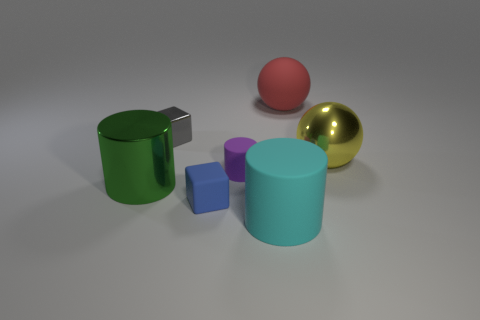What number of yellow shiny balls are there?
Your answer should be very brief. 1. How big is the block on the left side of the tiny matte block?
Your answer should be very brief. Small. How many yellow things have the same size as the green shiny cylinder?
Ensure brevity in your answer.  1. What is the large object that is on the right side of the metallic cylinder and on the left side of the large red rubber ball made of?
Make the answer very short. Rubber. What is the material of the blue thing that is the same size as the purple matte thing?
Offer a very short reply. Rubber. How big is the cylinder that is in front of the big metallic object to the left of the big matte object that is in front of the small matte cylinder?
Make the answer very short. Large. What size is the cyan thing that is the same material as the blue thing?
Keep it short and to the point. Large. Do the purple matte cylinder and the cube that is behind the tiny cylinder have the same size?
Give a very brief answer. Yes. What shape is the rubber thing behind the large yellow metallic object?
Make the answer very short. Sphere. There is a small block in front of the large metallic object that is in front of the metal sphere; is there a metal object right of it?
Give a very brief answer. Yes. 